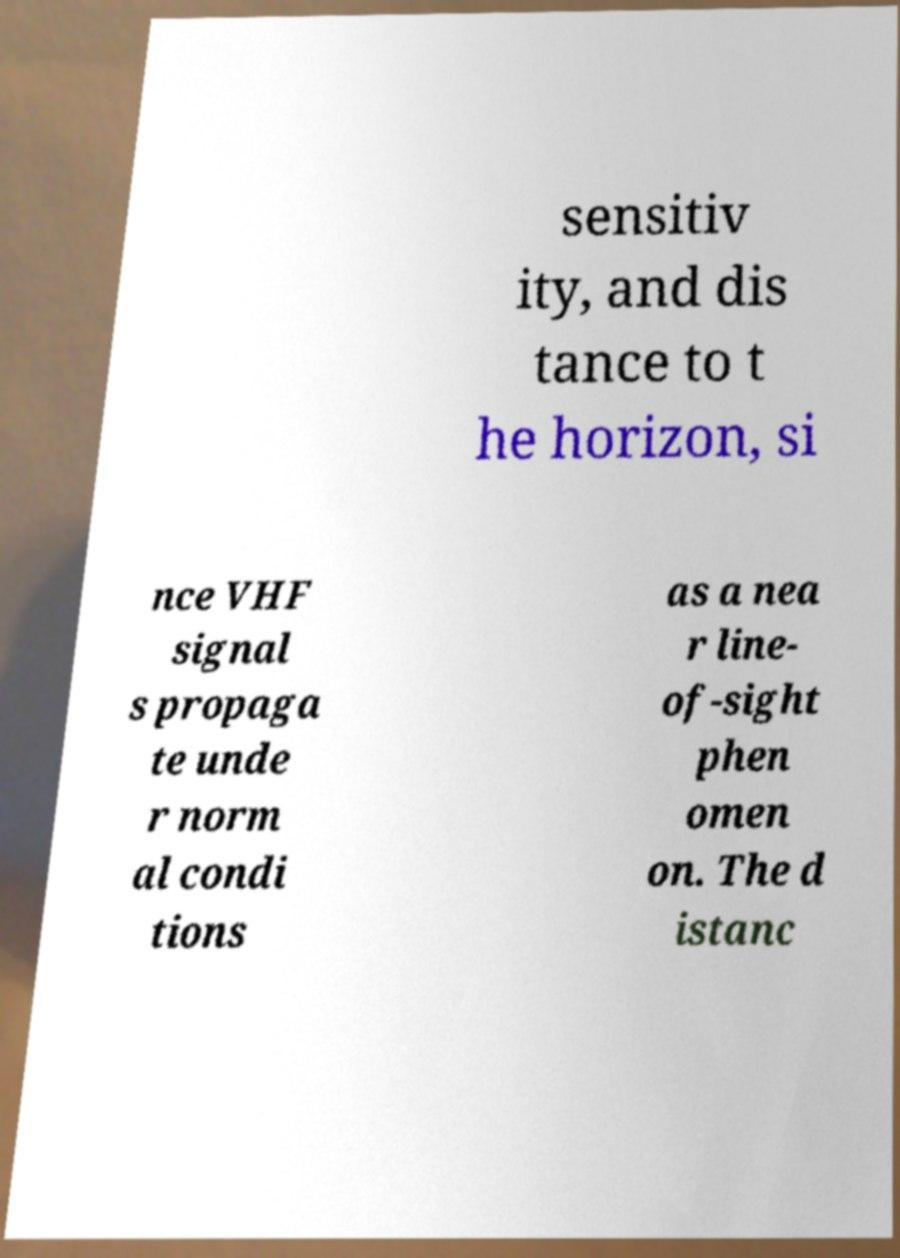What messages or text are displayed in this image? I need them in a readable, typed format. sensitiv ity, and dis tance to t he horizon, si nce VHF signal s propaga te unde r norm al condi tions as a nea r line- of-sight phen omen on. The d istanc 